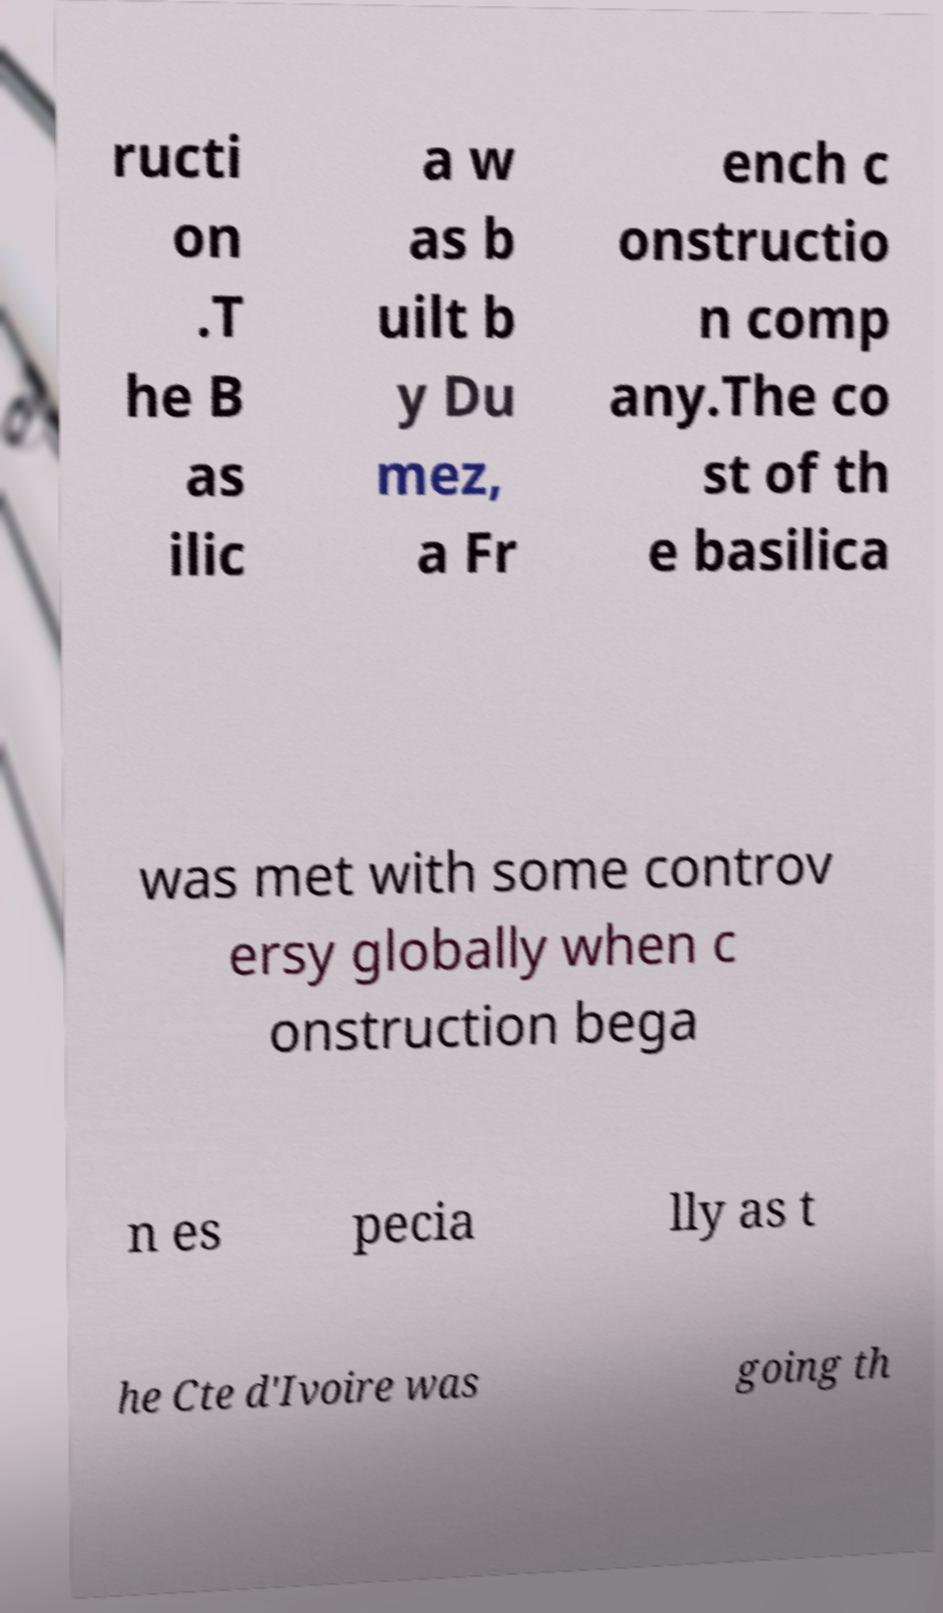Can you read and provide the text displayed in the image?This photo seems to have some interesting text. Can you extract and type it out for me? ructi on .T he B as ilic a w as b uilt b y Du mez, a Fr ench c onstructio n comp any.The co st of th e basilica was met with some controv ersy globally when c onstruction bega n es pecia lly as t he Cte d'Ivoire was going th 